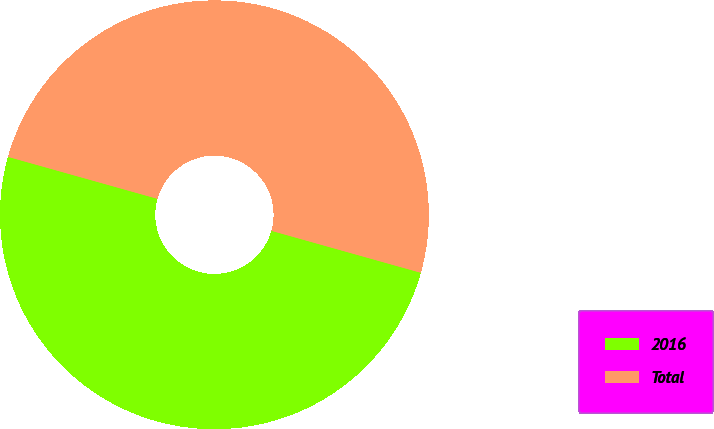<chart> <loc_0><loc_0><loc_500><loc_500><pie_chart><fcel>2016<fcel>Total<nl><fcel>50.0%<fcel>50.0%<nl></chart> 